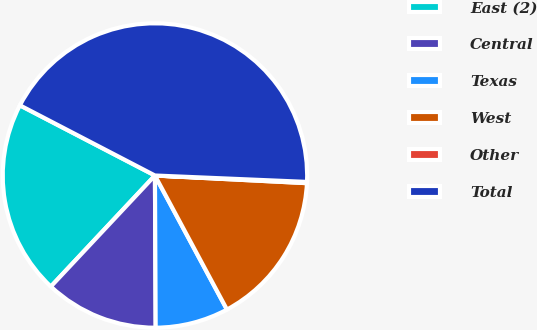Convert chart. <chart><loc_0><loc_0><loc_500><loc_500><pie_chart><fcel>East (2)<fcel>Central<fcel>Texas<fcel>West<fcel>Other<fcel>Total<nl><fcel>20.64%<fcel>12.06%<fcel>7.77%<fcel>16.35%<fcel>0.13%<fcel>43.04%<nl></chart> 